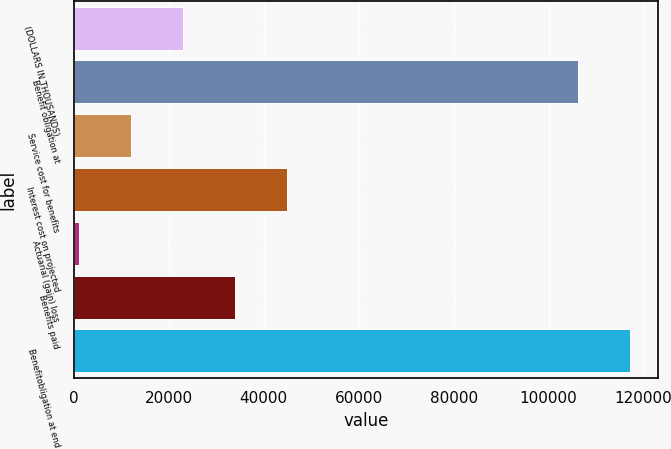Convert chart to OTSL. <chart><loc_0><loc_0><loc_500><loc_500><bar_chart><fcel>(DOLLARS IN THOUSANDS)<fcel>Benefit obligation at<fcel>Service cost for benefits<fcel>Interest cost on projected<fcel>Actuarial (gain) loss<fcel>Benefits paid<fcel>Benefitobligation at end<nl><fcel>23038.4<fcel>106166<fcel>12104.2<fcel>44906.8<fcel>1170<fcel>33972.6<fcel>117100<nl></chart> 